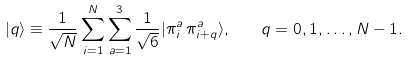Convert formula to latex. <formula><loc_0><loc_0><loc_500><loc_500>| q \rangle \equiv \frac { 1 } { \sqrt { N } } \sum _ { i = 1 } ^ { N } \sum _ { a = 1 } ^ { 3 } \frac { 1 } { \sqrt { 6 } } | \pi _ { i } ^ { a } \, \pi _ { i + q } ^ { a } \rangle , \quad q = 0 , 1 , \dots , N - 1 .</formula> 